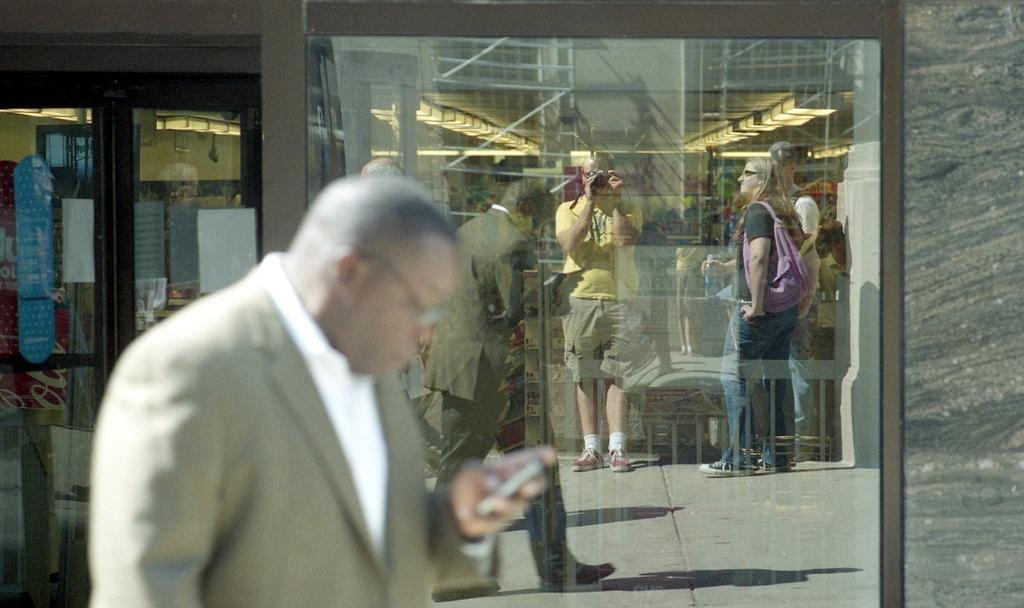Who is present in the image? There is a man in the image. What can be seen in the background of the image? There is a glass door in the background of the image. What is visible through the glass door? There are people visible through the glass door. What type of rose is the man holding in the image? There is no rose present in the image; the man is not holding anything. 